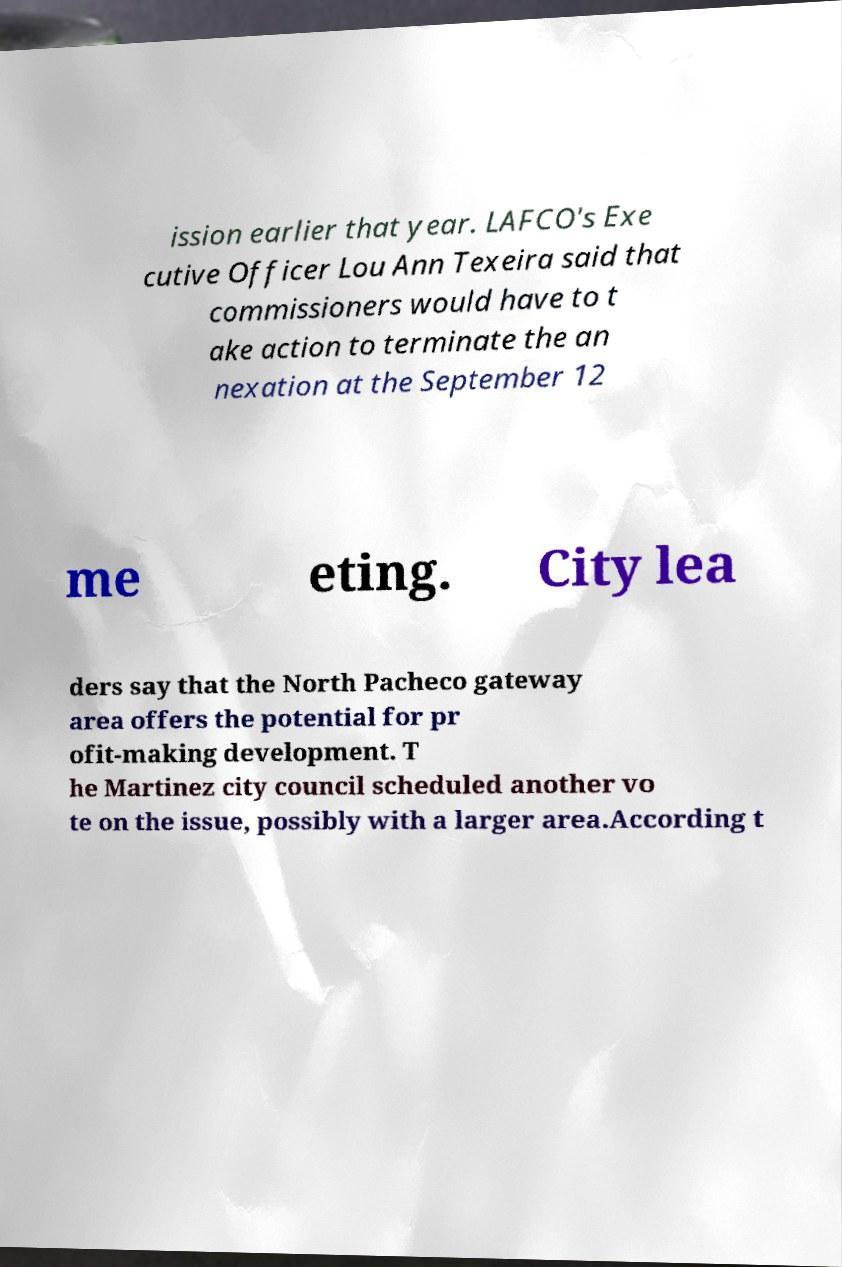Please identify and transcribe the text found in this image. ission earlier that year. LAFCO's Exe cutive Officer Lou Ann Texeira said that commissioners would have to t ake action to terminate the an nexation at the September 12 me eting. City lea ders say that the North Pacheco gateway area offers the potential for pr ofit-making development. T he Martinez city council scheduled another vo te on the issue, possibly with a larger area.According t 